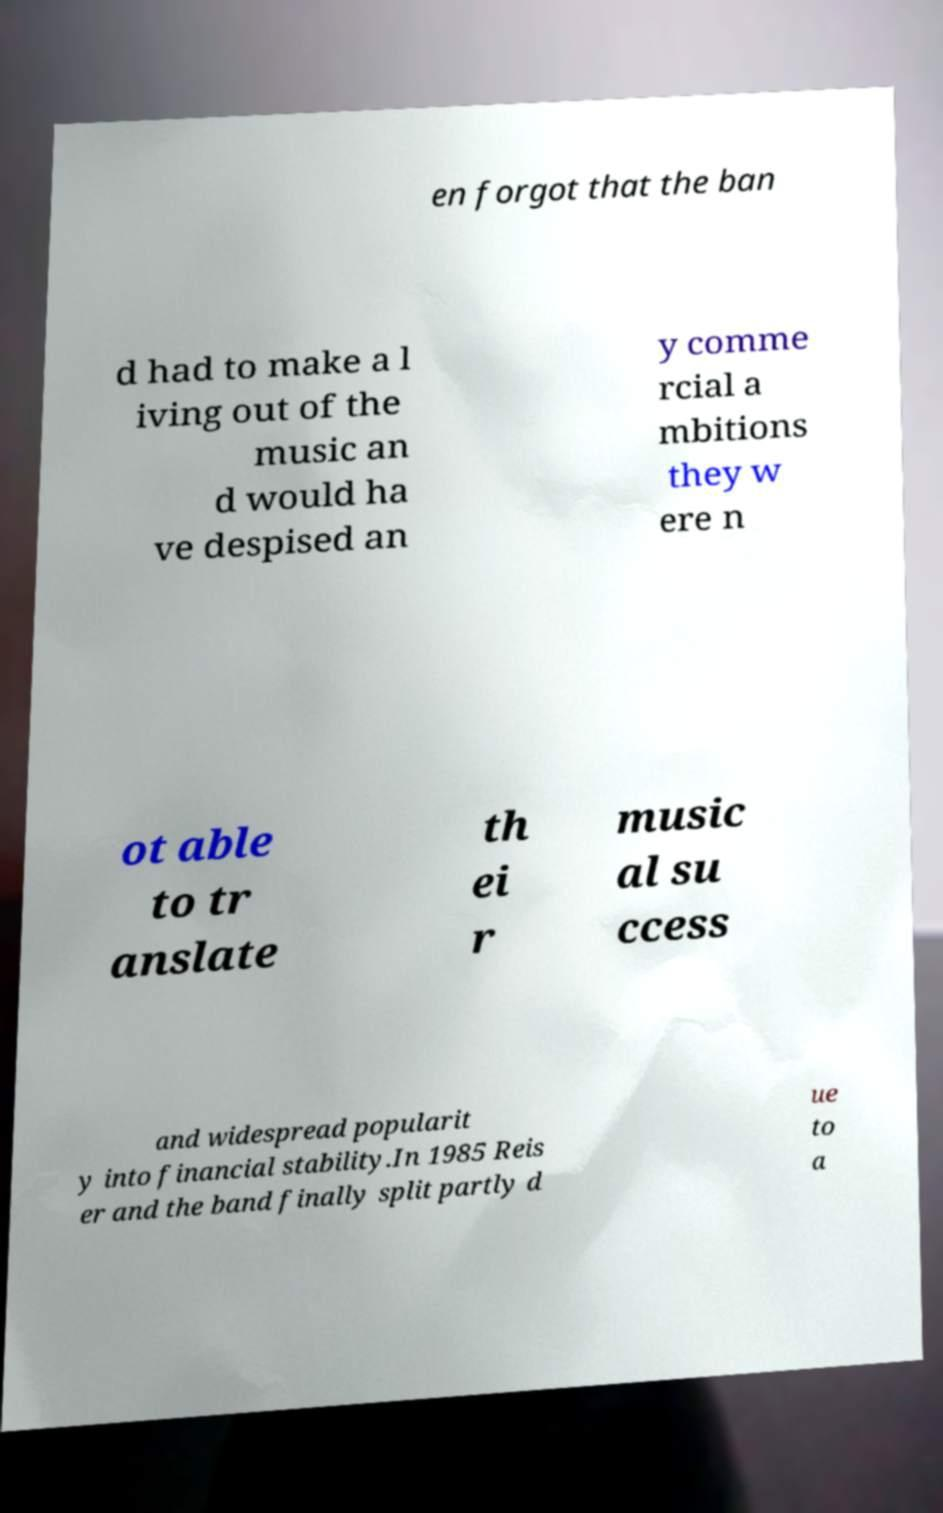Please identify and transcribe the text found in this image. en forgot that the ban d had to make a l iving out of the music an d would ha ve despised an y comme rcial a mbitions they w ere n ot able to tr anslate th ei r music al su ccess and widespread popularit y into financial stability.In 1985 Reis er and the band finally split partly d ue to a 